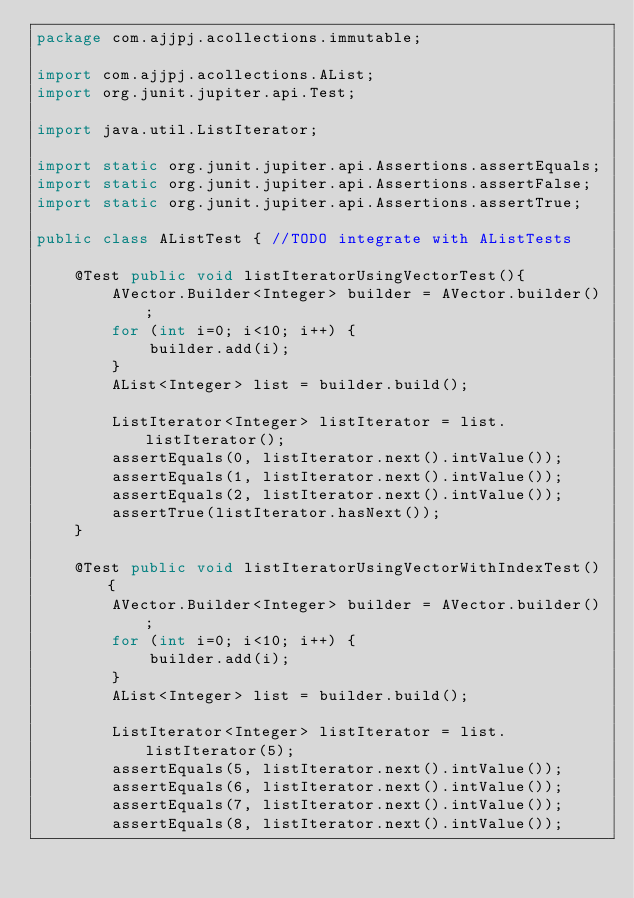<code> <loc_0><loc_0><loc_500><loc_500><_Java_>package com.ajjpj.acollections.immutable;

import com.ajjpj.acollections.AList;
import org.junit.jupiter.api.Test;

import java.util.ListIterator;

import static org.junit.jupiter.api.Assertions.assertEquals;
import static org.junit.jupiter.api.Assertions.assertFalse;
import static org.junit.jupiter.api.Assertions.assertTrue;

public class AListTest { //TODO integrate with AListTests

    @Test public void listIteratorUsingVectorTest(){
        AVector.Builder<Integer> builder = AVector.builder();
        for (int i=0; i<10; i++) {
            builder.add(i);
        }
        AList<Integer> list = builder.build();

        ListIterator<Integer> listIterator = list.listIterator();
        assertEquals(0, listIterator.next().intValue());
        assertEquals(1, listIterator.next().intValue());
        assertEquals(2, listIterator.next().intValue());
        assertTrue(listIterator.hasNext());
    }

    @Test public void listIteratorUsingVectorWithIndexTest(){
        AVector.Builder<Integer> builder = AVector.builder();
        for (int i=0; i<10; i++) {
            builder.add(i);
        }
        AList<Integer> list = builder.build();

        ListIterator<Integer> listIterator = list.listIterator(5);
        assertEquals(5, listIterator.next().intValue());
        assertEquals(6, listIterator.next().intValue());
        assertEquals(7, listIterator.next().intValue());
        assertEquals(8, listIterator.next().intValue());</code> 